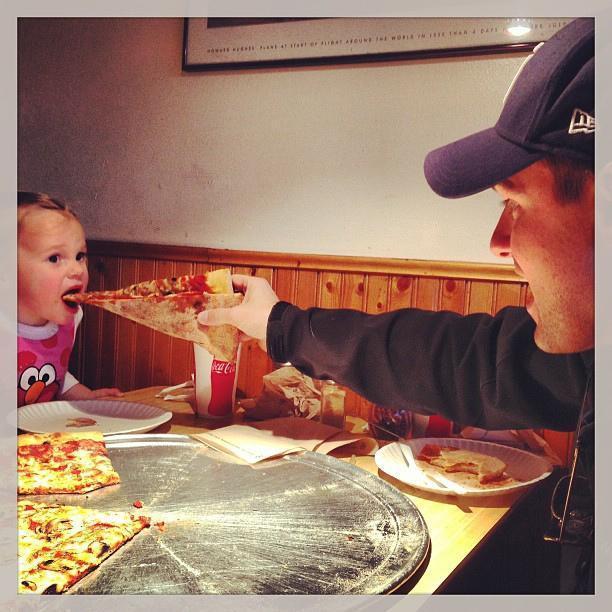How many people are visible?
Give a very brief answer. 2. 